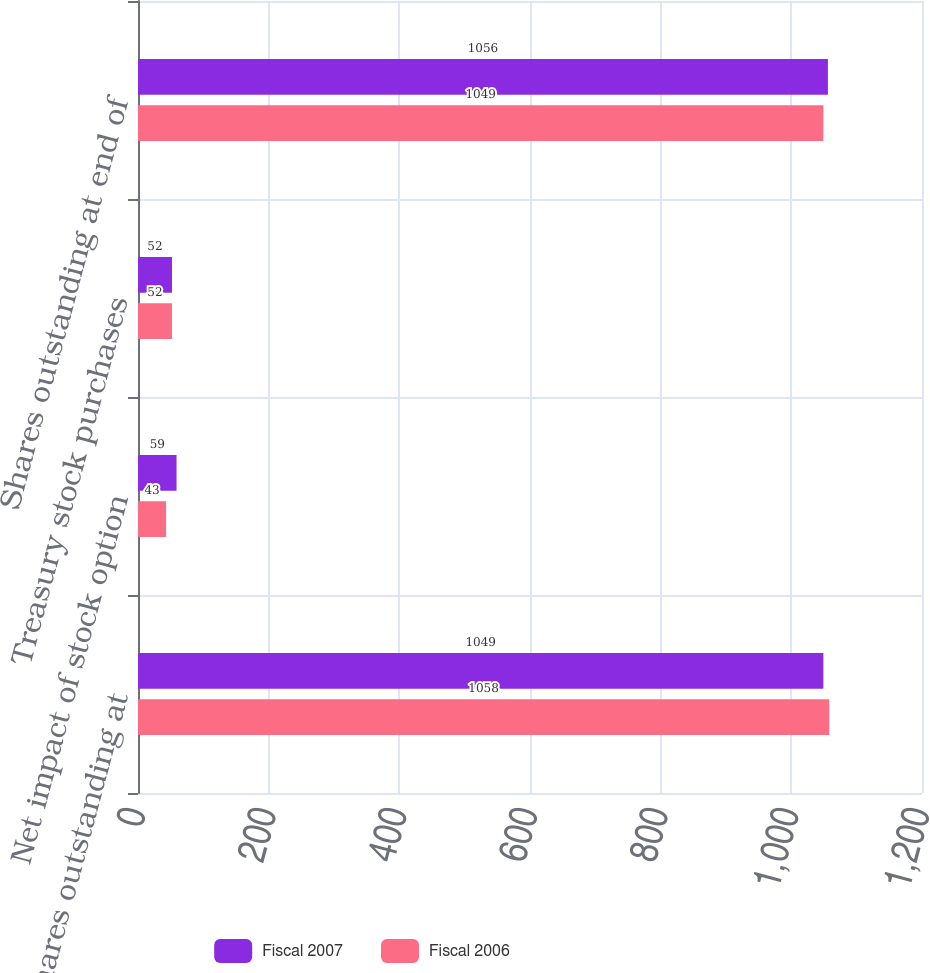Convert chart to OTSL. <chart><loc_0><loc_0><loc_500><loc_500><stacked_bar_chart><ecel><fcel>Shares outstanding at<fcel>Net impact of stock option<fcel>Treasury stock purchases<fcel>Shares outstanding at end of<nl><fcel>Fiscal 2007<fcel>1049<fcel>59<fcel>52<fcel>1056<nl><fcel>Fiscal 2006<fcel>1058<fcel>43<fcel>52<fcel>1049<nl></chart> 